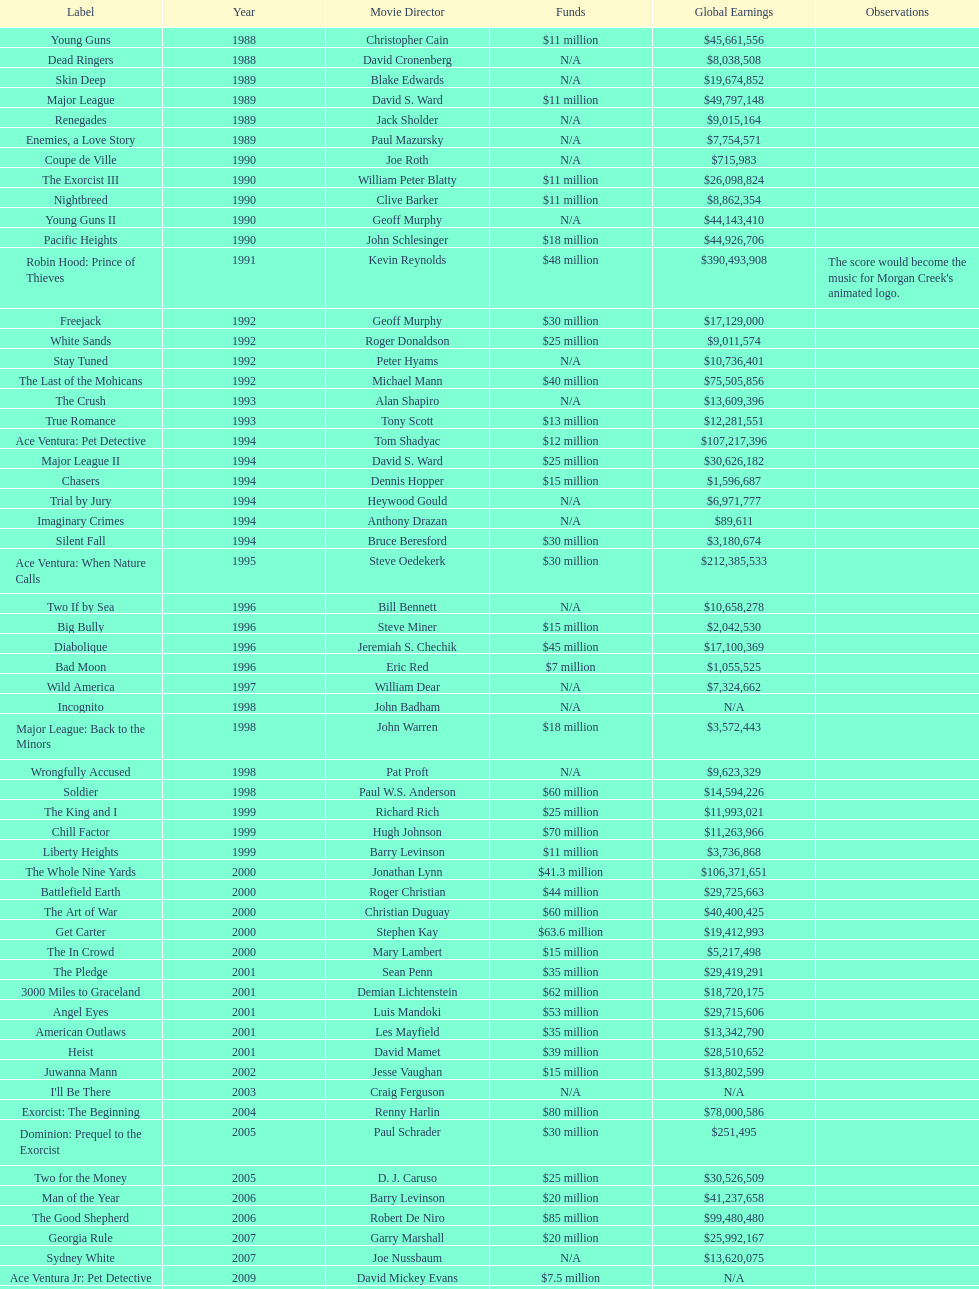Did true romance make more or less money than diabolique? Less. 